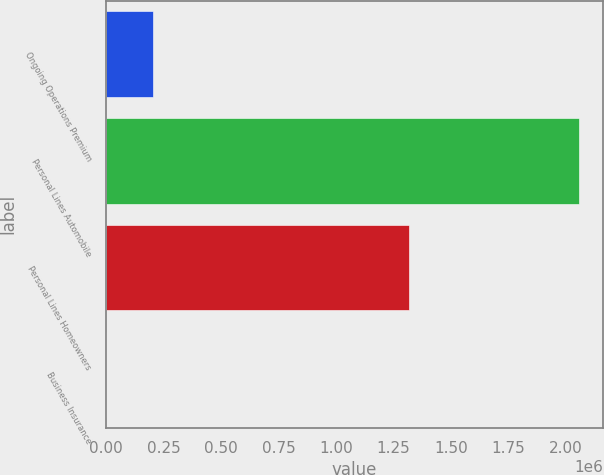Convert chart. <chart><loc_0><loc_0><loc_500><loc_500><bar_chart><fcel>Ongoing Operations Premium<fcel>Personal Lines Automobile<fcel>Personal Lines Homeowners<fcel>Business Insurance<nl><fcel>205891<fcel>2.05882e+06<fcel>1.31963e+06<fcel>9<nl></chart> 